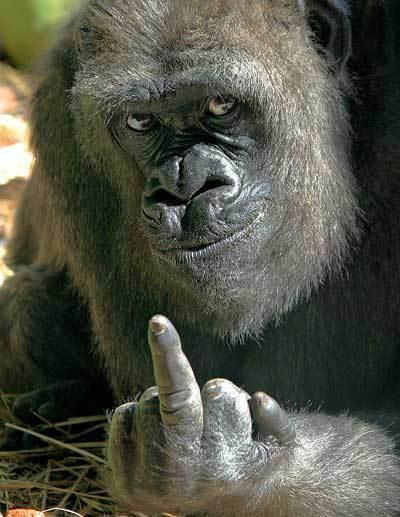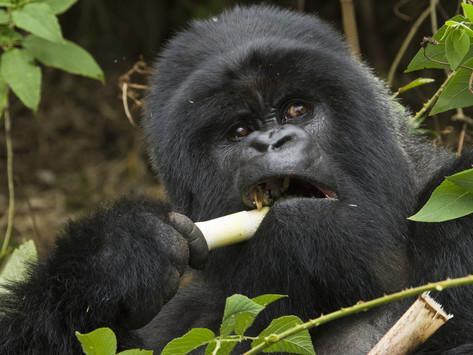The first image is the image on the left, the second image is the image on the right. Evaluate the accuracy of this statement regarding the images: "Only the image on the right depicts a gorilla holding food up to its mouth.". Is it true? Answer yes or no. Yes. The first image is the image on the left, the second image is the image on the right. Considering the images on both sides, is "Each image shows a gorilla grasping edible plant material, and at least one image shows a gorilla chewing on the item." valid? Answer yes or no. No. 